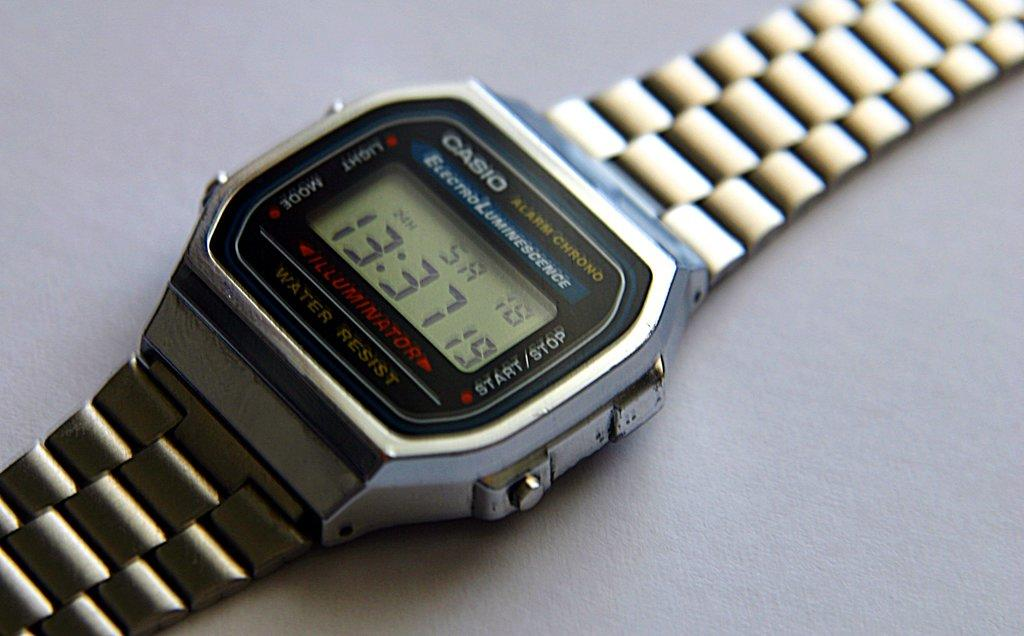<image>
Offer a succinct explanation of the picture presented. Casio watch that have the time and stop watch included 